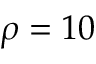Convert formula to latex. <formula><loc_0><loc_0><loc_500><loc_500>\rho = 1 0</formula> 